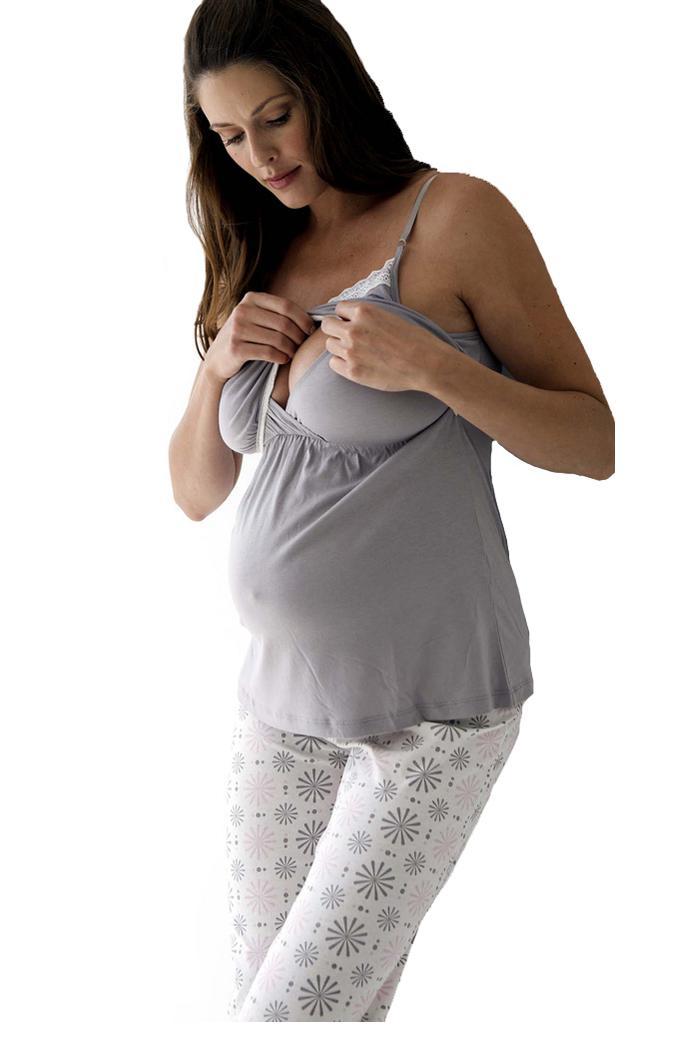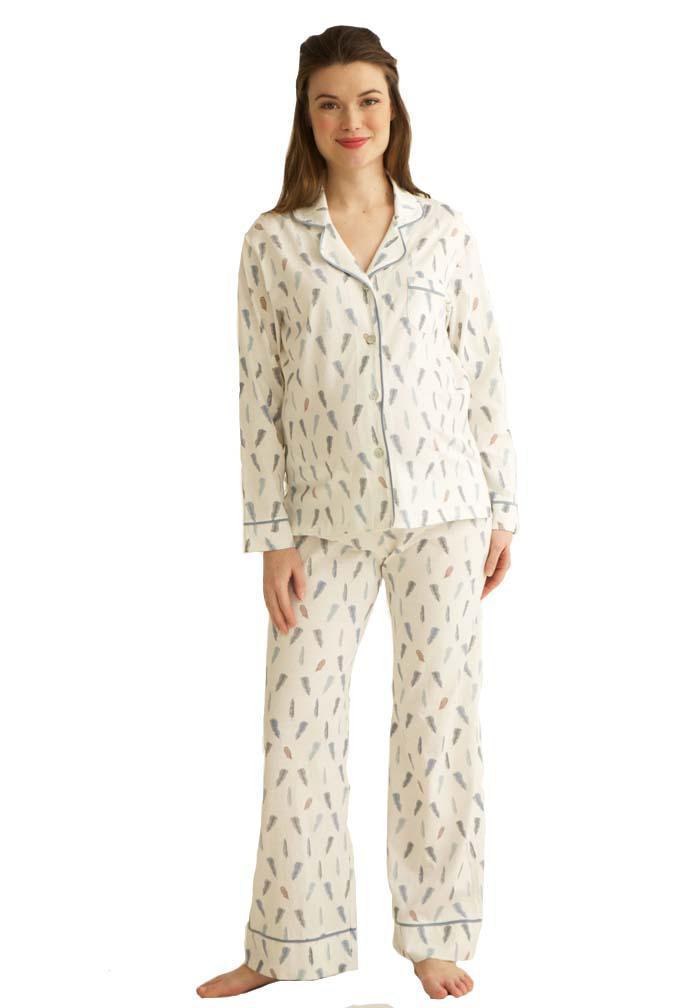The first image is the image on the left, the second image is the image on the right. For the images shown, is this caption "In at least 1 of the images, 1 person is wearing patterned white pants." true? Answer yes or no. Yes. The first image is the image on the left, the second image is the image on the right. For the images shown, is this caption "One women's pajama outfit has a matching short robe." true? Answer yes or no. No. 